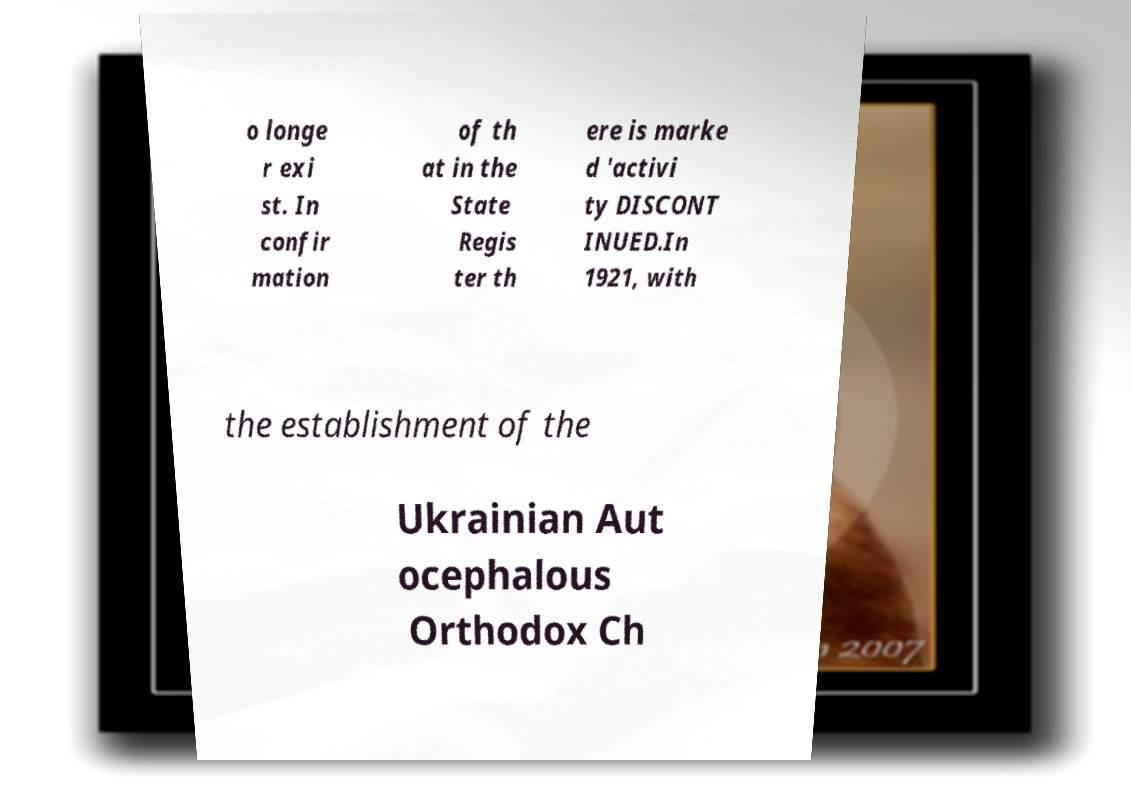There's text embedded in this image that I need extracted. Can you transcribe it verbatim? o longe r exi st. In confir mation of th at in the State Regis ter th ere is marke d 'activi ty DISCONT INUED.In 1921, with the establishment of the Ukrainian Aut ocephalous Orthodox Ch 